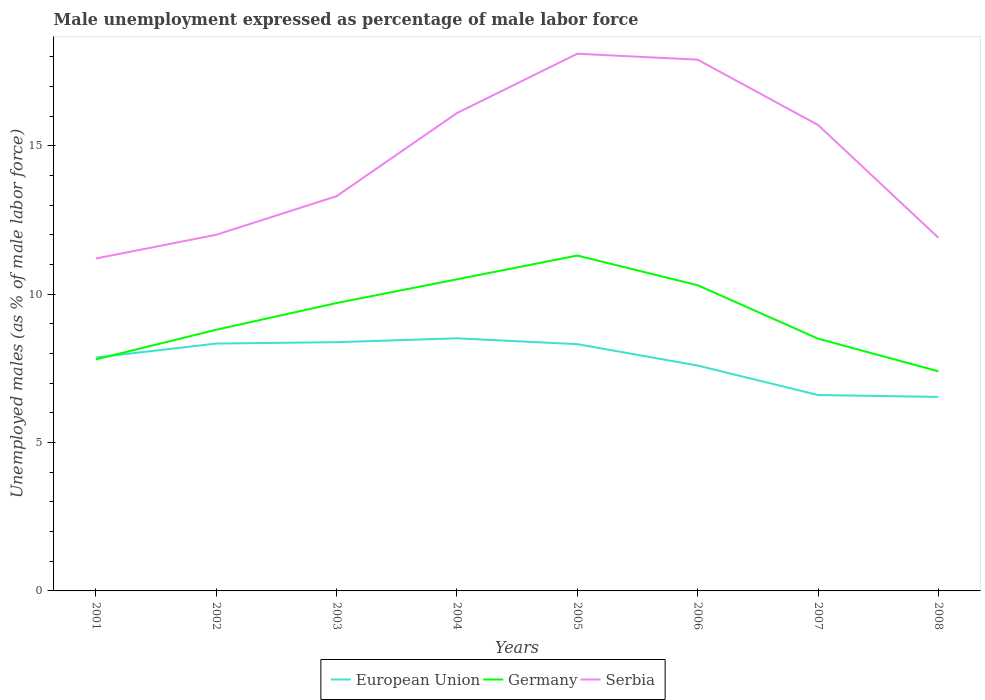Is the number of lines equal to the number of legend labels?
Your response must be concise. Yes. Across all years, what is the maximum unemployment in males in in Serbia?
Make the answer very short. 11.2. In which year was the unemployment in males in in Germany maximum?
Your response must be concise. 2008. What is the total unemployment in males in in Germany in the graph?
Make the answer very short. 1.4. What is the difference between the highest and the second highest unemployment in males in in Serbia?
Your response must be concise. 6.9. Is the unemployment in males in in Germany strictly greater than the unemployment in males in in European Union over the years?
Make the answer very short. No. How many lines are there?
Your answer should be very brief. 3. How many years are there in the graph?
Make the answer very short. 8. What is the difference between two consecutive major ticks on the Y-axis?
Offer a very short reply. 5. Are the values on the major ticks of Y-axis written in scientific E-notation?
Your answer should be very brief. No. Does the graph contain any zero values?
Provide a short and direct response. No. Does the graph contain grids?
Provide a short and direct response. No. How are the legend labels stacked?
Your answer should be compact. Horizontal. What is the title of the graph?
Offer a very short reply. Male unemployment expressed as percentage of male labor force. What is the label or title of the Y-axis?
Make the answer very short. Unemployed males (as % of male labor force). What is the Unemployed males (as % of male labor force) of European Union in 2001?
Offer a terse response. 7.86. What is the Unemployed males (as % of male labor force) in Germany in 2001?
Offer a very short reply. 7.8. What is the Unemployed males (as % of male labor force) of Serbia in 2001?
Give a very brief answer. 11.2. What is the Unemployed males (as % of male labor force) in European Union in 2002?
Your response must be concise. 8.33. What is the Unemployed males (as % of male labor force) of Germany in 2002?
Provide a succinct answer. 8.8. What is the Unemployed males (as % of male labor force) in European Union in 2003?
Offer a terse response. 8.38. What is the Unemployed males (as % of male labor force) in Germany in 2003?
Provide a short and direct response. 9.7. What is the Unemployed males (as % of male labor force) in Serbia in 2003?
Your answer should be very brief. 13.3. What is the Unemployed males (as % of male labor force) of European Union in 2004?
Your response must be concise. 8.51. What is the Unemployed males (as % of male labor force) in Germany in 2004?
Your answer should be compact. 10.5. What is the Unemployed males (as % of male labor force) of Serbia in 2004?
Your answer should be compact. 16.1. What is the Unemployed males (as % of male labor force) in European Union in 2005?
Provide a short and direct response. 8.31. What is the Unemployed males (as % of male labor force) in Germany in 2005?
Your answer should be compact. 11.3. What is the Unemployed males (as % of male labor force) of Serbia in 2005?
Provide a short and direct response. 18.1. What is the Unemployed males (as % of male labor force) in European Union in 2006?
Ensure brevity in your answer.  7.59. What is the Unemployed males (as % of male labor force) of Germany in 2006?
Offer a very short reply. 10.3. What is the Unemployed males (as % of male labor force) of Serbia in 2006?
Your answer should be very brief. 17.9. What is the Unemployed males (as % of male labor force) in European Union in 2007?
Your answer should be very brief. 6.6. What is the Unemployed males (as % of male labor force) of Germany in 2007?
Keep it short and to the point. 8.5. What is the Unemployed males (as % of male labor force) of Serbia in 2007?
Offer a very short reply. 15.7. What is the Unemployed males (as % of male labor force) of European Union in 2008?
Make the answer very short. 6.54. What is the Unemployed males (as % of male labor force) in Germany in 2008?
Keep it short and to the point. 7.4. What is the Unemployed males (as % of male labor force) in Serbia in 2008?
Give a very brief answer. 11.9. Across all years, what is the maximum Unemployed males (as % of male labor force) of European Union?
Ensure brevity in your answer.  8.51. Across all years, what is the maximum Unemployed males (as % of male labor force) of Germany?
Give a very brief answer. 11.3. Across all years, what is the maximum Unemployed males (as % of male labor force) in Serbia?
Your answer should be very brief. 18.1. Across all years, what is the minimum Unemployed males (as % of male labor force) of European Union?
Keep it short and to the point. 6.54. Across all years, what is the minimum Unemployed males (as % of male labor force) in Germany?
Provide a succinct answer. 7.4. Across all years, what is the minimum Unemployed males (as % of male labor force) in Serbia?
Ensure brevity in your answer.  11.2. What is the total Unemployed males (as % of male labor force) of European Union in the graph?
Offer a terse response. 62.14. What is the total Unemployed males (as % of male labor force) of Germany in the graph?
Provide a succinct answer. 74.3. What is the total Unemployed males (as % of male labor force) of Serbia in the graph?
Your answer should be compact. 116.2. What is the difference between the Unemployed males (as % of male labor force) in European Union in 2001 and that in 2002?
Give a very brief answer. -0.47. What is the difference between the Unemployed males (as % of male labor force) of Serbia in 2001 and that in 2002?
Make the answer very short. -0.8. What is the difference between the Unemployed males (as % of male labor force) of European Union in 2001 and that in 2003?
Ensure brevity in your answer.  -0.52. What is the difference between the Unemployed males (as % of male labor force) of European Union in 2001 and that in 2004?
Provide a short and direct response. -0.65. What is the difference between the Unemployed males (as % of male labor force) in Germany in 2001 and that in 2004?
Your answer should be compact. -2.7. What is the difference between the Unemployed males (as % of male labor force) of Serbia in 2001 and that in 2004?
Keep it short and to the point. -4.9. What is the difference between the Unemployed males (as % of male labor force) in European Union in 2001 and that in 2005?
Provide a short and direct response. -0.45. What is the difference between the Unemployed males (as % of male labor force) of Serbia in 2001 and that in 2005?
Provide a short and direct response. -6.9. What is the difference between the Unemployed males (as % of male labor force) of European Union in 2001 and that in 2006?
Ensure brevity in your answer.  0.27. What is the difference between the Unemployed males (as % of male labor force) in European Union in 2001 and that in 2007?
Provide a succinct answer. 1.26. What is the difference between the Unemployed males (as % of male labor force) of Germany in 2001 and that in 2007?
Provide a short and direct response. -0.7. What is the difference between the Unemployed males (as % of male labor force) in European Union in 2001 and that in 2008?
Offer a very short reply. 1.33. What is the difference between the Unemployed males (as % of male labor force) in Serbia in 2001 and that in 2008?
Your answer should be compact. -0.7. What is the difference between the Unemployed males (as % of male labor force) in European Union in 2002 and that in 2003?
Give a very brief answer. -0.05. What is the difference between the Unemployed males (as % of male labor force) of Serbia in 2002 and that in 2003?
Provide a succinct answer. -1.3. What is the difference between the Unemployed males (as % of male labor force) of European Union in 2002 and that in 2004?
Your answer should be compact. -0.18. What is the difference between the Unemployed males (as % of male labor force) of Germany in 2002 and that in 2004?
Make the answer very short. -1.7. What is the difference between the Unemployed males (as % of male labor force) of Serbia in 2002 and that in 2004?
Offer a very short reply. -4.1. What is the difference between the Unemployed males (as % of male labor force) of European Union in 2002 and that in 2005?
Give a very brief answer. 0.02. What is the difference between the Unemployed males (as % of male labor force) of European Union in 2002 and that in 2006?
Offer a very short reply. 0.74. What is the difference between the Unemployed males (as % of male labor force) in European Union in 2002 and that in 2007?
Ensure brevity in your answer.  1.73. What is the difference between the Unemployed males (as % of male labor force) of Serbia in 2002 and that in 2007?
Offer a terse response. -3.7. What is the difference between the Unemployed males (as % of male labor force) of European Union in 2002 and that in 2008?
Make the answer very short. 1.8. What is the difference between the Unemployed males (as % of male labor force) in European Union in 2003 and that in 2004?
Your answer should be compact. -0.13. What is the difference between the Unemployed males (as % of male labor force) of Serbia in 2003 and that in 2004?
Your answer should be very brief. -2.8. What is the difference between the Unemployed males (as % of male labor force) of European Union in 2003 and that in 2005?
Offer a terse response. 0.07. What is the difference between the Unemployed males (as % of male labor force) in Germany in 2003 and that in 2005?
Offer a terse response. -1.6. What is the difference between the Unemployed males (as % of male labor force) in Serbia in 2003 and that in 2005?
Make the answer very short. -4.8. What is the difference between the Unemployed males (as % of male labor force) in European Union in 2003 and that in 2006?
Your answer should be compact. 0.79. What is the difference between the Unemployed males (as % of male labor force) in Germany in 2003 and that in 2006?
Your answer should be very brief. -0.6. What is the difference between the Unemployed males (as % of male labor force) of Serbia in 2003 and that in 2006?
Provide a short and direct response. -4.6. What is the difference between the Unemployed males (as % of male labor force) of European Union in 2003 and that in 2007?
Your response must be concise. 1.78. What is the difference between the Unemployed males (as % of male labor force) in Germany in 2003 and that in 2007?
Offer a terse response. 1.2. What is the difference between the Unemployed males (as % of male labor force) of Serbia in 2003 and that in 2007?
Keep it short and to the point. -2.4. What is the difference between the Unemployed males (as % of male labor force) of European Union in 2003 and that in 2008?
Provide a short and direct response. 1.85. What is the difference between the Unemployed males (as % of male labor force) of Germany in 2003 and that in 2008?
Provide a short and direct response. 2.3. What is the difference between the Unemployed males (as % of male labor force) in Serbia in 2003 and that in 2008?
Your answer should be very brief. 1.4. What is the difference between the Unemployed males (as % of male labor force) in European Union in 2004 and that in 2005?
Your answer should be compact. 0.2. What is the difference between the Unemployed males (as % of male labor force) in European Union in 2004 and that in 2006?
Ensure brevity in your answer.  0.92. What is the difference between the Unemployed males (as % of male labor force) in Germany in 2004 and that in 2006?
Your answer should be very brief. 0.2. What is the difference between the Unemployed males (as % of male labor force) of European Union in 2004 and that in 2007?
Your answer should be compact. 1.91. What is the difference between the Unemployed males (as % of male labor force) in Germany in 2004 and that in 2007?
Make the answer very short. 2. What is the difference between the Unemployed males (as % of male labor force) of European Union in 2004 and that in 2008?
Ensure brevity in your answer.  1.98. What is the difference between the Unemployed males (as % of male labor force) of Germany in 2004 and that in 2008?
Your answer should be very brief. 3.1. What is the difference between the Unemployed males (as % of male labor force) of Serbia in 2004 and that in 2008?
Offer a very short reply. 4.2. What is the difference between the Unemployed males (as % of male labor force) of European Union in 2005 and that in 2006?
Keep it short and to the point. 0.72. What is the difference between the Unemployed males (as % of male labor force) of Germany in 2005 and that in 2006?
Offer a terse response. 1. What is the difference between the Unemployed males (as % of male labor force) in Serbia in 2005 and that in 2006?
Offer a very short reply. 0.2. What is the difference between the Unemployed males (as % of male labor force) in European Union in 2005 and that in 2007?
Provide a succinct answer. 1.71. What is the difference between the Unemployed males (as % of male labor force) of Germany in 2005 and that in 2007?
Provide a succinct answer. 2.8. What is the difference between the Unemployed males (as % of male labor force) of European Union in 2005 and that in 2008?
Offer a very short reply. 1.78. What is the difference between the Unemployed males (as % of male labor force) of Serbia in 2005 and that in 2008?
Your answer should be very brief. 6.2. What is the difference between the Unemployed males (as % of male labor force) in European Union in 2006 and that in 2008?
Your answer should be compact. 1.06. What is the difference between the Unemployed males (as % of male labor force) of European Union in 2007 and that in 2008?
Offer a very short reply. 0.07. What is the difference between the Unemployed males (as % of male labor force) in European Union in 2001 and the Unemployed males (as % of male labor force) in Germany in 2002?
Offer a very short reply. -0.94. What is the difference between the Unemployed males (as % of male labor force) of European Union in 2001 and the Unemployed males (as % of male labor force) of Serbia in 2002?
Your answer should be compact. -4.14. What is the difference between the Unemployed males (as % of male labor force) in Germany in 2001 and the Unemployed males (as % of male labor force) in Serbia in 2002?
Offer a terse response. -4.2. What is the difference between the Unemployed males (as % of male labor force) in European Union in 2001 and the Unemployed males (as % of male labor force) in Germany in 2003?
Provide a succinct answer. -1.84. What is the difference between the Unemployed males (as % of male labor force) of European Union in 2001 and the Unemployed males (as % of male labor force) of Serbia in 2003?
Keep it short and to the point. -5.44. What is the difference between the Unemployed males (as % of male labor force) in Germany in 2001 and the Unemployed males (as % of male labor force) in Serbia in 2003?
Keep it short and to the point. -5.5. What is the difference between the Unemployed males (as % of male labor force) of European Union in 2001 and the Unemployed males (as % of male labor force) of Germany in 2004?
Keep it short and to the point. -2.64. What is the difference between the Unemployed males (as % of male labor force) of European Union in 2001 and the Unemployed males (as % of male labor force) of Serbia in 2004?
Offer a terse response. -8.24. What is the difference between the Unemployed males (as % of male labor force) in Germany in 2001 and the Unemployed males (as % of male labor force) in Serbia in 2004?
Give a very brief answer. -8.3. What is the difference between the Unemployed males (as % of male labor force) in European Union in 2001 and the Unemployed males (as % of male labor force) in Germany in 2005?
Provide a short and direct response. -3.44. What is the difference between the Unemployed males (as % of male labor force) in European Union in 2001 and the Unemployed males (as % of male labor force) in Serbia in 2005?
Offer a terse response. -10.24. What is the difference between the Unemployed males (as % of male labor force) in Germany in 2001 and the Unemployed males (as % of male labor force) in Serbia in 2005?
Provide a succinct answer. -10.3. What is the difference between the Unemployed males (as % of male labor force) in European Union in 2001 and the Unemployed males (as % of male labor force) in Germany in 2006?
Offer a very short reply. -2.44. What is the difference between the Unemployed males (as % of male labor force) of European Union in 2001 and the Unemployed males (as % of male labor force) of Serbia in 2006?
Give a very brief answer. -10.04. What is the difference between the Unemployed males (as % of male labor force) of European Union in 2001 and the Unemployed males (as % of male labor force) of Germany in 2007?
Offer a very short reply. -0.64. What is the difference between the Unemployed males (as % of male labor force) of European Union in 2001 and the Unemployed males (as % of male labor force) of Serbia in 2007?
Offer a very short reply. -7.84. What is the difference between the Unemployed males (as % of male labor force) in Germany in 2001 and the Unemployed males (as % of male labor force) in Serbia in 2007?
Your answer should be compact. -7.9. What is the difference between the Unemployed males (as % of male labor force) of European Union in 2001 and the Unemployed males (as % of male labor force) of Germany in 2008?
Provide a succinct answer. 0.46. What is the difference between the Unemployed males (as % of male labor force) in European Union in 2001 and the Unemployed males (as % of male labor force) in Serbia in 2008?
Your answer should be very brief. -4.04. What is the difference between the Unemployed males (as % of male labor force) in Germany in 2001 and the Unemployed males (as % of male labor force) in Serbia in 2008?
Your response must be concise. -4.1. What is the difference between the Unemployed males (as % of male labor force) in European Union in 2002 and the Unemployed males (as % of male labor force) in Germany in 2003?
Give a very brief answer. -1.37. What is the difference between the Unemployed males (as % of male labor force) of European Union in 2002 and the Unemployed males (as % of male labor force) of Serbia in 2003?
Keep it short and to the point. -4.97. What is the difference between the Unemployed males (as % of male labor force) of European Union in 2002 and the Unemployed males (as % of male labor force) of Germany in 2004?
Offer a terse response. -2.17. What is the difference between the Unemployed males (as % of male labor force) in European Union in 2002 and the Unemployed males (as % of male labor force) in Serbia in 2004?
Give a very brief answer. -7.77. What is the difference between the Unemployed males (as % of male labor force) of Germany in 2002 and the Unemployed males (as % of male labor force) of Serbia in 2004?
Offer a very short reply. -7.3. What is the difference between the Unemployed males (as % of male labor force) of European Union in 2002 and the Unemployed males (as % of male labor force) of Germany in 2005?
Offer a very short reply. -2.97. What is the difference between the Unemployed males (as % of male labor force) of European Union in 2002 and the Unemployed males (as % of male labor force) of Serbia in 2005?
Offer a terse response. -9.77. What is the difference between the Unemployed males (as % of male labor force) in Germany in 2002 and the Unemployed males (as % of male labor force) in Serbia in 2005?
Provide a succinct answer. -9.3. What is the difference between the Unemployed males (as % of male labor force) of European Union in 2002 and the Unemployed males (as % of male labor force) of Germany in 2006?
Give a very brief answer. -1.97. What is the difference between the Unemployed males (as % of male labor force) of European Union in 2002 and the Unemployed males (as % of male labor force) of Serbia in 2006?
Provide a succinct answer. -9.57. What is the difference between the Unemployed males (as % of male labor force) of European Union in 2002 and the Unemployed males (as % of male labor force) of Germany in 2007?
Keep it short and to the point. -0.17. What is the difference between the Unemployed males (as % of male labor force) in European Union in 2002 and the Unemployed males (as % of male labor force) in Serbia in 2007?
Make the answer very short. -7.37. What is the difference between the Unemployed males (as % of male labor force) in Germany in 2002 and the Unemployed males (as % of male labor force) in Serbia in 2007?
Give a very brief answer. -6.9. What is the difference between the Unemployed males (as % of male labor force) of European Union in 2002 and the Unemployed males (as % of male labor force) of Germany in 2008?
Ensure brevity in your answer.  0.93. What is the difference between the Unemployed males (as % of male labor force) in European Union in 2002 and the Unemployed males (as % of male labor force) in Serbia in 2008?
Your answer should be compact. -3.57. What is the difference between the Unemployed males (as % of male labor force) in Germany in 2002 and the Unemployed males (as % of male labor force) in Serbia in 2008?
Provide a succinct answer. -3.1. What is the difference between the Unemployed males (as % of male labor force) in European Union in 2003 and the Unemployed males (as % of male labor force) in Germany in 2004?
Give a very brief answer. -2.12. What is the difference between the Unemployed males (as % of male labor force) of European Union in 2003 and the Unemployed males (as % of male labor force) of Serbia in 2004?
Provide a short and direct response. -7.72. What is the difference between the Unemployed males (as % of male labor force) of European Union in 2003 and the Unemployed males (as % of male labor force) of Germany in 2005?
Make the answer very short. -2.92. What is the difference between the Unemployed males (as % of male labor force) in European Union in 2003 and the Unemployed males (as % of male labor force) in Serbia in 2005?
Offer a terse response. -9.72. What is the difference between the Unemployed males (as % of male labor force) in Germany in 2003 and the Unemployed males (as % of male labor force) in Serbia in 2005?
Provide a succinct answer. -8.4. What is the difference between the Unemployed males (as % of male labor force) in European Union in 2003 and the Unemployed males (as % of male labor force) in Germany in 2006?
Provide a succinct answer. -1.92. What is the difference between the Unemployed males (as % of male labor force) of European Union in 2003 and the Unemployed males (as % of male labor force) of Serbia in 2006?
Give a very brief answer. -9.52. What is the difference between the Unemployed males (as % of male labor force) of European Union in 2003 and the Unemployed males (as % of male labor force) of Germany in 2007?
Give a very brief answer. -0.12. What is the difference between the Unemployed males (as % of male labor force) of European Union in 2003 and the Unemployed males (as % of male labor force) of Serbia in 2007?
Make the answer very short. -7.32. What is the difference between the Unemployed males (as % of male labor force) of Germany in 2003 and the Unemployed males (as % of male labor force) of Serbia in 2007?
Offer a terse response. -6. What is the difference between the Unemployed males (as % of male labor force) in European Union in 2003 and the Unemployed males (as % of male labor force) in Germany in 2008?
Keep it short and to the point. 0.98. What is the difference between the Unemployed males (as % of male labor force) of European Union in 2003 and the Unemployed males (as % of male labor force) of Serbia in 2008?
Give a very brief answer. -3.52. What is the difference between the Unemployed males (as % of male labor force) of European Union in 2004 and the Unemployed males (as % of male labor force) of Germany in 2005?
Make the answer very short. -2.79. What is the difference between the Unemployed males (as % of male labor force) of European Union in 2004 and the Unemployed males (as % of male labor force) of Serbia in 2005?
Your response must be concise. -9.59. What is the difference between the Unemployed males (as % of male labor force) of Germany in 2004 and the Unemployed males (as % of male labor force) of Serbia in 2005?
Keep it short and to the point. -7.6. What is the difference between the Unemployed males (as % of male labor force) of European Union in 2004 and the Unemployed males (as % of male labor force) of Germany in 2006?
Offer a terse response. -1.79. What is the difference between the Unemployed males (as % of male labor force) of European Union in 2004 and the Unemployed males (as % of male labor force) of Serbia in 2006?
Give a very brief answer. -9.39. What is the difference between the Unemployed males (as % of male labor force) of European Union in 2004 and the Unemployed males (as % of male labor force) of Germany in 2007?
Your response must be concise. 0.01. What is the difference between the Unemployed males (as % of male labor force) in European Union in 2004 and the Unemployed males (as % of male labor force) in Serbia in 2007?
Your response must be concise. -7.19. What is the difference between the Unemployed males (as % of male labor force) in Germany in 2004 and the Unemployed males (as % of male labor force) in Serbia in 2007?
Provide a succinct answer. -5.2. What is the difference between the Unemployed males (as % of male labor force) of European Union in 2004 and the Unemployed males (as % of male labor force) of Germany in 2008?
Your response must be concise. 1.11. What is the difference between the Unemployed males (as % of male labor force) of European Union in 2004 and the Unemployed males (as % of male labor force) of Serbia in 2008?
Ensure brevity in your answer.  -3.39. What is the difference between the Unemployed males (as % of male labor force) in European Union in 2005 and the Unemployed males (as % of male labor force) in Germany in 2006?
Offer a very short reply. -1.99. What is the difference between the Unemployed males (as % of male labor force) of European Union in 2005 and the Unemployed males (as % of male labor force) of Serbia in 2006?
Provide a succinct answer. -9.59. What is the difference between the Unemployed males (as % of male labor force) of Germany in 2005 and the Unemployed males (as % of male labor force) of Serbia in 2006?
Provide a succinct answer. -6.6. What is the difference between the Unemployed males (as % of male labor force) of European Union in 2005 and the Unemployed males (as % of male labor force) of Germany in 2007?
Give a very brief answer. -0.19. What is the difference between the Unemployed males (as % of male labor force) of European Union in 2005 and the Unemployed males (as % of male labor force) of Serbia in 2007?
Keep it short and to the point. -7.39. What is the difference between the Unemployed males (as % of male labor force) of Germany in 2005 and the Unemployed males (as % of male labor force) of Serbia in 2007?
Your answer should be compact. -4.4. What is the difference between the Unemployed males (as % of male labor force) of European Union in 2005 and the Unemployed males (as % of male labor force) of Germany in 2008?
Provide a short and direct response. 0.91. What is the difference between the Unemployed males (as % of male labor force) in European Union in 2005 and the Unemployed males (as % of male labor force) in Serbia in 2008?
Your response must be concise. -3.59. What is the difference between the Unemployed males (as % of male labor force) in Germany in 2005 and the Unemployed males (as % of male labor force) in Serbia in 2008?
Offer a very short reply. -0.6. What is the difference between the Unemployed males (as % of male labor force) in European Union in 2006 and the Unemployed males (as % of male labor force) in Germany in 2007?
Your response must be concise. -0.91. What is the difference between the Unemployed males (as % of male labor force) in European Union in 2006 and the Unemployed males (as % of male labor force) in Serbia in 2007?
Your answer should be very brief. -8.11. What is the difference between the Unemployed males (as % of male labor force) in European Union in 2006 and the Unemployed males (as % of male labor force) in Germany in 2008?
Your response must be concise. 0.19. What is the difference between the Unemployed males (as % of male labor force) of European Union in 2006 and the Unemployed males (as % of male labor force) of Serbia in 2008?
Your response must be concise. -4.31. What is the difference between the Unemployed males (as % of male labor force) in Germany in 2006 and the Unemployed males (as % of male labor force) in Serbia in 2008?
Make the answer very short. -1.6. What is the difference between the Unemployed males (as % of male labor force) in European Union in 2007 and the Unemployed males (as % of male labor force) in Germany in 2008?
Ensure brevity in your answer.  -0.8. What is the difference between the Unemployed males (as % of male labor force) in European Union in 2007 and the Unemployed males (as % of male labor force) in Serbia in 2008?
Keep it short and to the point. -5.3. What is the average Unemployed males (as % of male labor force) in European Union per year?
Keep it short and to the point. 7.77. What is the average Unemployed males (as % of male labor force) of Germany per year?
Your answer should be compact. 9.29. What is the average Unemployed males (as % of male labor force) in Serbia per year?
Keep it short and to the point. 14.53. In the year 2001, what is the difference between the Unemployed males (as % of male labor force) in European Union and Unemployed males (as % of male labor force) in Germany?
Ensure brevity in your answer.  0.06. In the year 2001, what is the difference between the Unemployed males (as % of male labor force) in European Union and Unemployed males (as % of male labor force) in Serbia?
Your answer should be compact. -3.34. In the year 2002, what is the difference between the Unemployed males (as % of male labor force) in European Union and Unemployed males (as % of male labor force) in Germany?
Your answer should be very brief. -0.47. In the year 2002, what is the difference between the Unemployed males (as % of male labor force) of European Union and Unemployed males (as % of male labor force) of Serbia?
Ensure brevity in your answer.  -3.67. In the year 2003, what is the difference between the Unemployed males (as % of male labor force) in European Union and Unemployed males (as % of male labor force) in Germany?
Your answer should be compact. -1.32. In the year 2003, what is the difference between the Unemployed males (as % of male labor force) of European Union and Unemployed males (as % of male labor force) of Serbia?
Provide a succinct answer. -4.92. In the year 2003, what is the difference between the Unemployed males (as % of male labor force) of Germany and Unemployed males (as % of male labor force) of Serbia?
Make the answer very short. -3.6. In the year 2004, what is the difference between the Unemployed males (as % of male labor force) in European Union and Unemployed males (as % of male labor force) in Germany?
Offer a very short reply. -1.99. In the year 2004, what is the difference between the Unemployed males (as % of male labor force) of European Union and Unemployed males (as % of male labor force) of Serbia?
Your answer should be compact. -7.59. In the year 2005, what is the difference between the Unemployed males (as % of male labor force) in European Union and Unemployed males (as % of male labor force) in Germany?
Ensure brevity in your answer.  -2.99. In the year 2005, what is the difference between the Unemployed males (as % of male labor force) of European Union and Unemployed males (as % of male labor force) of Serbia?
Give a very brief answer. -9.79. In the year 2006, what is the difference between the Unemployed males (as % of male labor force) in European Union and Unemployed males (as % of male labor force) in Germany?
Provide a short and direct response. -2.71. In the year 2006, what is the difference between the Unemployed males (as % of male labor force) of European Union and Unemployed males (as % of male labor force) of Serbia?
Keep it short and to the point. -10.31. In the year 2007, what is the difference between the Unemployed males (as % of male labor force) of European Union and Unemployed males (as % of male labor force) of Germany?
Keep it short and to the point. -1.9. In the year 2007, what is the difference between the Unemployed males (as % of male labor force) in European Union and Unemployed males (as % of male labor force) in Serbia?
Give a very brief answer. -9.1. In the year 2007, what is the difference between the Unemployed males (as % of male labor force) of Germany and Unemployed males (as % of male labor force) of Serbia?
Provide a succinct answer. -7.2. In the year 2008, what is the difference between the Unemployed males (as % of male labor force) in European Union and Unemployed males (as % of male labor force) in Germany?
Keep it short and to the point. -0.86. In the year 2008, what is the difference between the Unemployed males (as % of male labor force) in European Union and Unemployed males (as % of male labor force) in Serbia?
Provide a succinct answer. -5.36. In the year 2008, what is the difference between the Unemployed males (as % of male labor force) in Germany and Unemployed males (as % of male labor force) in Serbia?
Your answer should be very brief. -4.5. What is the ratio of the Unemployed males (as % of male labor force) of European Union in 2001 to that in 2002?
Provide a short and direct response. 0.94. What is the ratio of the Unemployed males (as % of male labor force) of Germany in 2001 to that in 2002?
Offer a very short reply. 0.89. What is the ratio of the Unemployed males (as % of male labor force) in Serbia in 2001 to that in 2002?
Your answer should be compact. 0.93. What is the ratio of the Unemployed males (as % of male labor force) of European Union in 2001 to that in 2003?
Give a very brief answer. 0.94. What is the ratio of the Unemployed males (as % of male labor force) in Germany in 2001 to that in 2003?
Your response must be concise. 0.8. What is the ratio of the Unemployed males (as % of male labor force) of Serbia in 2001 to that in 2003?
Offer a very short reply. 0.84. What is the ratio of the Unemployed males (as % of male labor force) of European Union in 2001 to that in 2004?
Ensure brevity in your answer.  0.92. What is the ratio of the Unemployed males (as % of male labor force) in Germany in 2001 to that in 2004?
Offer a very short reply. 0.74. What is the ratio of the Unemployed males (as % of male labor force) of Serbia in 2001 to that in 2004?
Provide a succinct answer. 0.7. What is the ratio of the Unemployed males (as % of male labor force) of European Union in 2001 to that in 2005?
Keep it short and to the point. 0.95. What is the ratio of the Unemployed males (as % of male labor force) in Germany in 2001 to that in 2005?
Keep it short and to the point. 0.69. What is the ratio of the Unemployed males (as % of male labor force) of Serbia in 2001 to that in 2005?
Your answer should be compact. 0.62. What is the ratio of the Unemployed males (as % of male labor force) in European Union in 2001 to that in 2006?
Provide a succinct answer. 1.04. What is the ratio of the Unemployed males (as % of male labor force) of Germany in 2001 to that in 2006?
Give a very brief answer. 0.76. What is the ratio of the Unemployed males (as % of male labor force) in Serbia in 2001 to that in 2006?
Make the answer very short. 0.63. What is the ratio of the Unemployed males (as % of male labor force) in European Union in 2001 to that in 2007?
Your response must be concise. 1.19. What is the ratio of the Unemployed males (as % of male labor force) in Germany in 2001 to that in 2007?
Keep it short and to the point. 0.92. What is the ratio of the Unemployed males (as % of male labor force) in Serbia in 2001 to that in 2007?
Keep it short and to the point. 0.71. What is the ratio of the Unemployed males (as % of male labor force) in European Union in 2001 to that in 2008?
Your answer should be compact. 1.2. What is the ratio of the Unemployed males (as % of male labor force) of Germany in 2001 to that in 2008?
Provide a succinct answer. 1.05. What is the ratio of the Unemployed males (as % of male labor force) of Serbia in 2001 to that in 2008?
Offer a very short reply. 0.94. What is the ratio of the Unemployed males (as % of male labor force) in Germany in 2002 to that in 2003?
Make the answer very short. 0.91. What is the ratio of the Unemployed males (as % of male labor force) of Serbia in 2002 to that in 2003?
Keep it short and to the point. 0.9. What is the ratio of the Unemployed males (as % of male labor force) in European Union in 2002 to that in 2004?
Your answer should be compact. 0.98. What is the ratio of the Unemployed males (as % of male labor force) of Germany in 2002 to that in 2004?
Ensure brevity in your answer.  0.84. What is the ratio of the Unemployed males (as % of male labor force) of Serbia in 2002 to that in 2004?
Provide a short and direct response. 0.75. What is the ratio of the Unemployed males (as % of male labor force) of European Union in 2002 to that in 2005?
Provide a succinct answer. 1. What is the ratio of the Unemployed males (as % of male labor force) of Germany in 2002 to that in 2005?
Offer a terse response. 0.78. What is the ratio of the Unemployed males (as % of male labor force) in Serbia in 2002 to that in 2005?
Offer a terse response. 0.66. What is the ratio of the Unemployed males (as % of male labor force) of European Union in 2002 to that in 2006?
Provide a succinct answer. 1.1. What is the ratio of the Unemployed males (as % of male labor force) in Germany in 2002 to that in 2006?
Offer a terse response. 0.85. What is the ratio of the Unemployed males (as % of male labor force) of Serbia in 2002 to that in 2006?
Your answer should be very brief. 0.67. What is the ratio of the Unemployed males (as % of male labor force) in European Union in 2002 to that in 2007?
Your answer should be compact. 1.26. What is the ratio of the Unemployed males (as % of male labor force) in Germany in 2002 to that in 2007?
Keep it short and to the point. 1.04. What is the ratio of the Unemployed males (as % of male labor force) in Serbia in 2002 to that in 2007?
Keep it short and to the point. 0.76. What is the ratio of the Unemployed males (as % of male labor force) in European Union in 2002 to that in 2008?
Offer a terse response. 1.28. What is the ratio of the Unemployed males (as % of male labor force) in Germany in 2002 to that in 2008?
Provide a short and direct response. 1.19. What is the ratio of the Unemployed males (as % of male labor force) of Serbia in 2002 to that in 2008?
Provide a succinct answer. 1.01. What is the ratio of the Unemployed males (as % of male labor force) in European Union in 2003 to that in 2004?
Provide a succinct answer. 0.98. What is the ratio of the Unemployed males (as % of male labor force) in Germany in 2003 to that in 2004?
Offer a terse response. 0.92. What is the ratio of the Unemployed males (as % of male labor force) in Serbia in 2003 to that in 2004?
Your response must be concise. 0.83. What is the ratio of the Unemployed males (as % of male labor force) in European Union in 2003 to that in 2005?
Make the answer very short. 1.01. What is the ratio of the Unemployed males (as % of male labor force) in Germany in 2003 to that in 2005?
Keep it short and to the point. 0.86. What is the ratio of the Unemployed males (as % of male labor force) of Serbia in 2003 to that in 2005?
Your answer should be very brief. 0.73. What is the ratio of the Unemployed males (as % of male labor force) of European Union in 2003 to that in 2006?
Give a very brief answer. 1.1. What is the ratio of the Unemployed males (as % of male labor force) in Germany in 2003 to that in 2006?
Make the answer very short. 0.94. What is the ratio of the Unemployed males (as % of male labor force) in Serbia in 2003 to that in 2006?
Offer a terse response. 0.74. What is the ratio of the Unemployed males (as % of male labor force) in European Union in 2003 to that in 2007?
Offer a very short reply. 1.27. What is the ratio of the Unemployed males (as % of male labor force) in Germany in 2003 to that in 2007?
Keep it short and to the point. 1.14. What is the ratio of the Unemployed males (as % of male labor force) of Serbia in 2003 to that in 2007?
Your response must be concise. 0.85. What is the ratio of the Unemployed males (as % of male labor force) in European Union in 2003 to that in 2008?
Your answer should be very brief. 1.28. What is the ratio of the Unemployed males (as % of male labor force) of Germany in 2003 to that in 2008?
Keep it short and to the point. 1.31. What is the ratio of the Unemployed males (as % of male labor force) of Serbia in 2003 to that in 2008?
Make the answer very short. 1.12. What is the ratio of the Unemployed males (as % of male labor force) of European Union in 2004 to that in 2005?
Your answer should be very brief. 1.02. What is the ratio of the Unemployed males (as % of male labor force) of Germany in 2004 to that in 2005?
Provide a short and direct response. 0.93. What is the ratio of the Unemployed males (as % of male labor force) in Serbia in 2004 to that in 2005?
Offer a terse response. 0.89. What is the ratio of the Unemployed males (as % of male labor force) in European Union in 2004 to that in 2006?
Offer a terse response. 1.12. What is the ratio of the Unemployed males (as % of male labor force) in Germany in 2004 to that in 2006?
Give a very brief answer. 1.02. What is the ratio of the Unemployed males (as % of male labor force) of Serbia in 2004 to that in 2006?
Keep it short and to the point. 0.9. What is the ratio of the Unemployed males (as % of male labor force) of European Union in 2004 to that in 2007?
Your response must be concise. 1.29. What is the ratio of the Unemployed males (as % of male labor force) of Germany in 2004 to that in 2007?
Provide a short and direct response. 1.24. What is the ratio of the Unemployed males (as % of male labor force) in Serbia in 2004 to that in 2007?
Your answer should be compact. 1.03. What is the ratio of the Unemployed males (as % of male labor force) of European Union in 2004 to that in 2008?
Provide a short and direct response. 1.3. What is the ratio of the Unemployed males (as % of male labor force) of Germany in 2004 to that in 2008?
Your response must be concise. 1.42. What is the ratio of the Unemployed males (as % of male labor force) of Serbia in 2004 to that in 2008?
Make the answer very short. 1.35. What is the ratio of the Unemployed males (as % of male labor force) in European Union in 2005 to that in 2006?
Make the answer very short. 1.09. What is the ratio of the Unemployed males (as % of male labor force) of Germany in 2005 to that in 2006?
Make the answer very short. 1.1. What is the ratio of the Unemployed males (as % of male labor force) in Serbia in 2005 to that in 2006?
Offer a very short reply. 1.01. What is the ratio of the Unemployed males (as % of male labor force) of European Union in 2005 to that in 2007?
Provide a short and direct response. 1.26. What is the ratio of the Unemployed males (as % of male labor force) of Germany in 2005 to that in 2007?
Provide a succinct answer. 1.33. What is the ratio of the Unemployed males (as % of male labor force) in Serbia in 2005 to that in 2007?
Make the answer very short. 1.15. What is the ratio of the Unemployed males (as % of male labor force) of European Union in 2005 to that in 2008?
Your answer should be very brief. 1.27. What is the ratio of the Unemployed males (as % of male labor force) of Germany in 2005 to that in 2008?
Make the answer very short. 1.53. What is the ratio of the Unemployed males (as % of male labor force) in Serbia in 2005 to that in 2008?
Keep it short and to the point. 1.52. What is the ratio of the Unemployed males (as % of male labor force) in European Union in 2006 to that in 2007?
Ensure brevity in your answer.  1.15. What is the ratio of the Unemployed males (as % of male labor force) in Germany in 2006 to that in 2007?
Make the answer very short. 1.21. What is the ratio of the Unemployed males (as % of male labor force) of Serbia in 2006 to that in 2007?
Ensure brevity in your answer.  1.14. What is the ratio of the Unemployed males (as % of male labor force) of European Union in 2006 to that in 2008?
Keep it short and to the point. 1.16. What is the ratio of the Unemployed males (as % of male labor force) in Germany in 2006 to that in 2008?
Provide a succinct answer. 1.39. What is the ratio of the Unemployed males (as % of male labor force) in Serbia in 2006 to that in 2008?
Your answer should be compact. 1.5. What is the ratio of the Unemployed males (as % of male labor force) of European Union in 2007 to that in 2008?
Provide a short and direct response. 1.01. What is the ratio of the Unemployed males (as % of male labor force) of Germany in 2007 to that in 2008?
Give a very brief answer. 1.15. What is the ratio of the Unemployed males (as % of male labor force) in Serbia in 2007 to that in 2008?
Offer a very short reply. 1.32. What is the difference between the highest and the second highest Unemployed males (as % of male labor force) of European Union?
Your response must be concise. 0.13. What is the difference between the highest and the second highest Unemployed males (as % of male labor force) of Serbia?
Keep it short and to the point. 0.2. What is the difference between the highest and the lowest Unemployed males (as % of male labor force) in European Union?
Offer a terse response. 1.98. What is the difference between the highest and the lowest Unemployed males (as % of male labor force) in Germany?
Offer a terse response. 3.9. What is the difference between the highest and the lowest Unemployed males (as % of male labor force) of Serbia?
Provide a succinct answer. 6.9. 